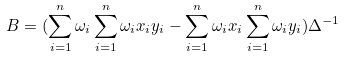<formula> <loc_0><loc_0><loc_500><loc_500>B = ( \sum ^ { n } _ { i = 1 } \omega _ { i } \sum ^ { n } _ { i = 1 } \omega _ { i } x _ { i } y _ { i } - \sum ^ { n } _ { i = 1 } \omega _ { i } x _ { i } \sum ^ { n } _ { i = 1 } \omega _ { i } y _ { i } ) \Delta ^ { - 1 }</formula> 